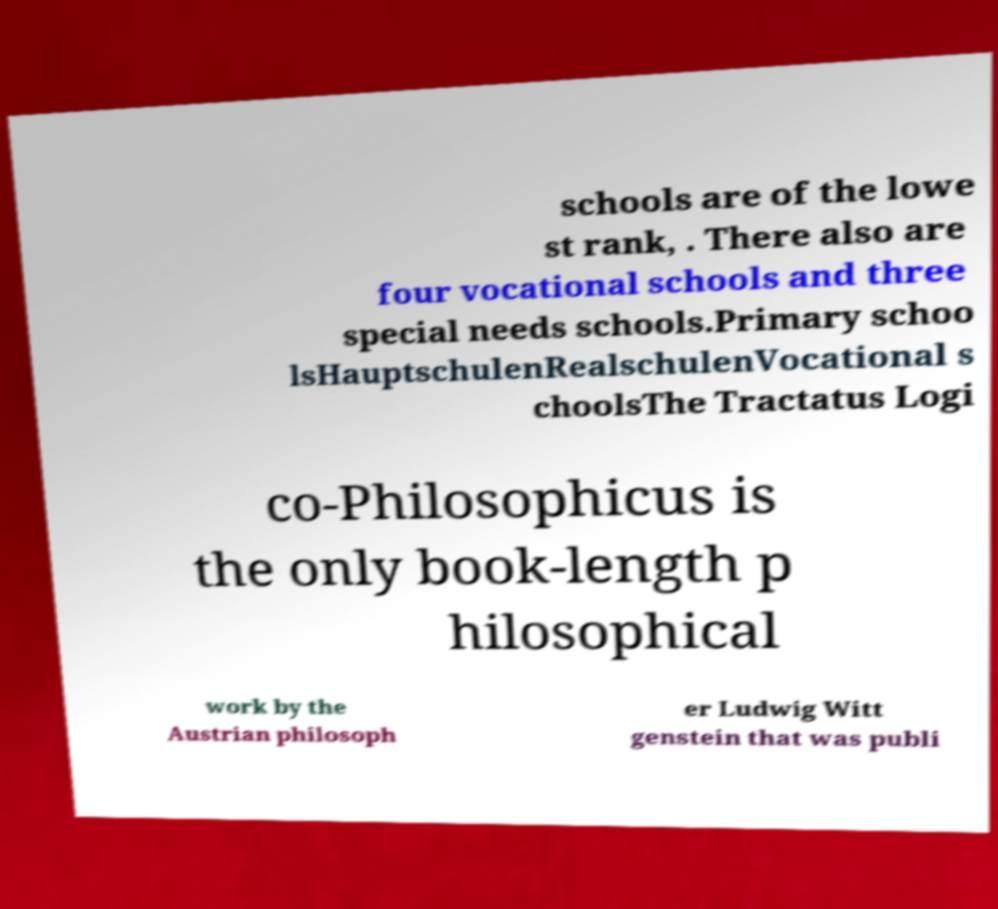Please identify and transcribe the text found in this image. schools are of the lowe st rank, . There also are four vocational schools and three special needs schools.Primary schoo lsHauptschulenRealschulenVocational s choolsThe Tractatus Logi co-Philosophicus is the only book-length p hilosophical work by the Austrian philosoph er Ludwig Witt genstein that was publi 